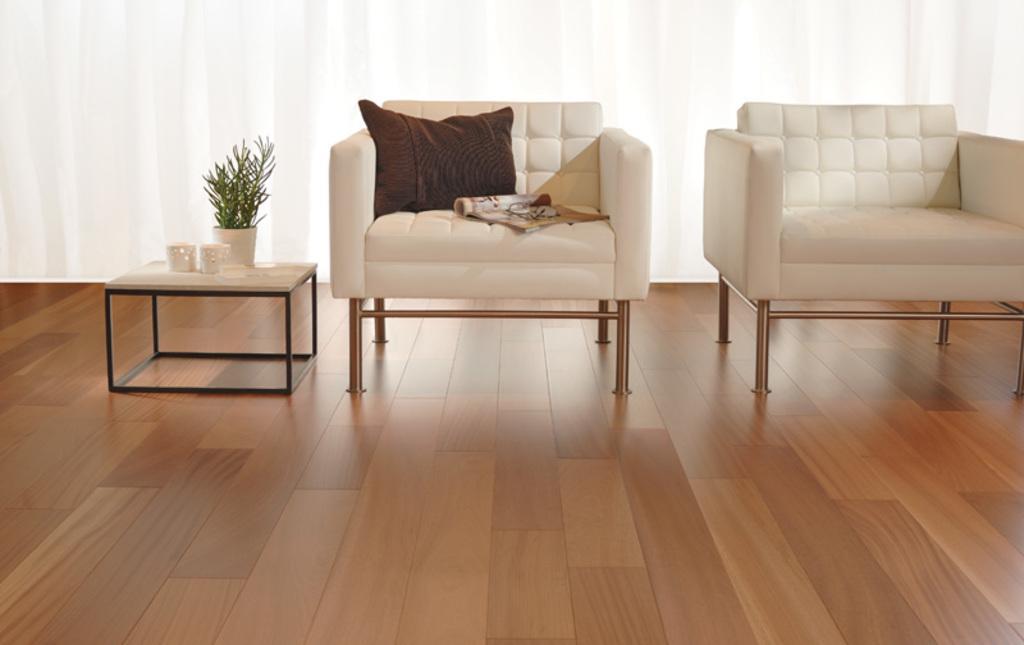In one or two sentences, can you explain what this image depicts? In the image we can see there are two chairs and on one chair there is pillow and on the table there is plant in a pot. 